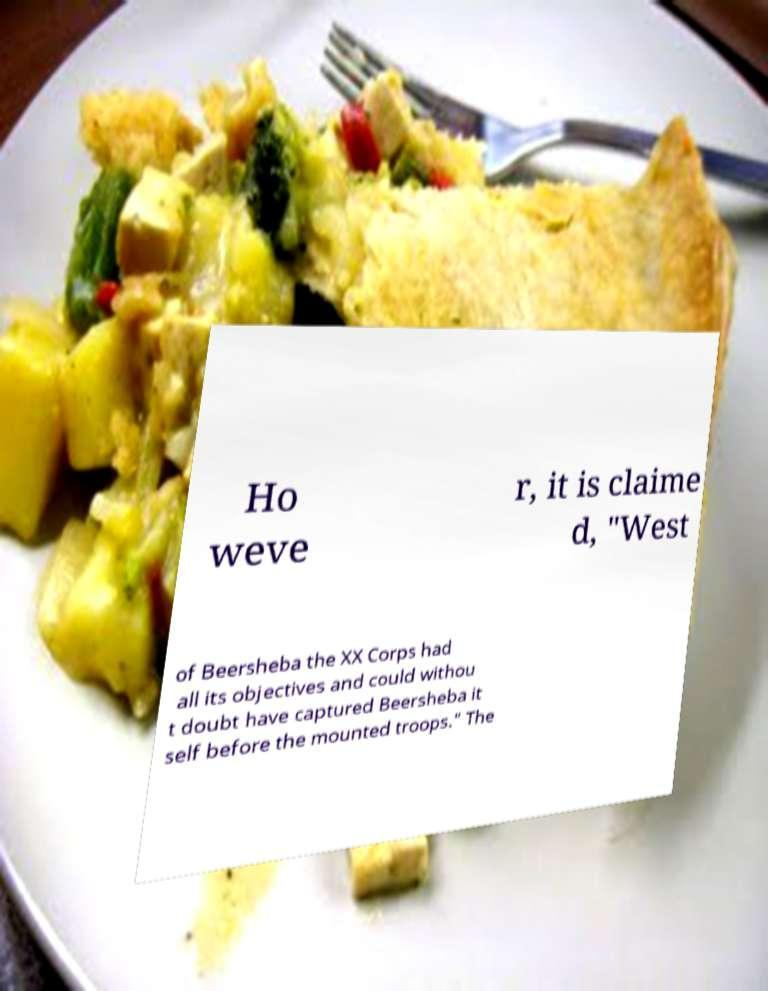For documentation purposes, I need the text within this image transcribed. Could you provide that? Ho weve r, it is claime d, "West of Beersheba the XX Corps had all its objectives and could withou t doubt have captured Beersheba it self before the mounted troops." The 